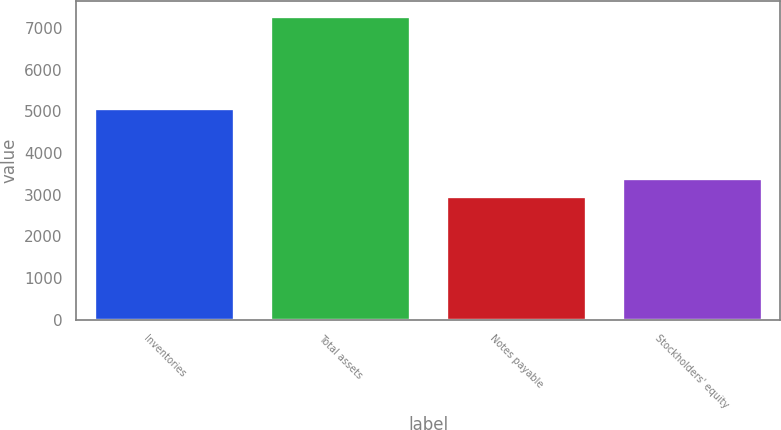Convert chart to OTSL. <chart><loc_0><loc_0><loc_500><loc_500><bar_chart><fcel>Inventories<fcel>Total assets<fcel>Notes payable<fcel>Stockholders' equity<nl><fcel>5082.3<fcel>7279.4<fcel>2963.2<fcel>3394.82<nl></chart> 